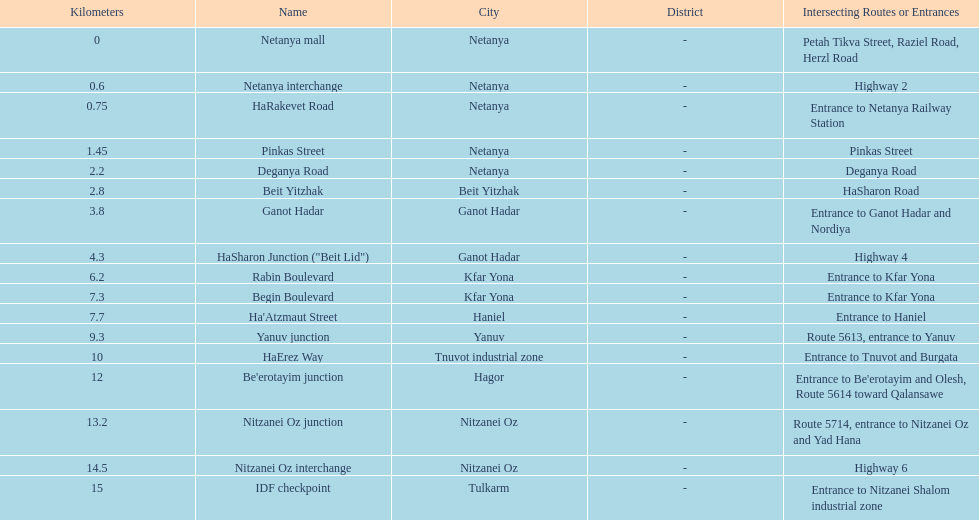After you complete deganya road, what portion comes next? Beit Yitzhak. 